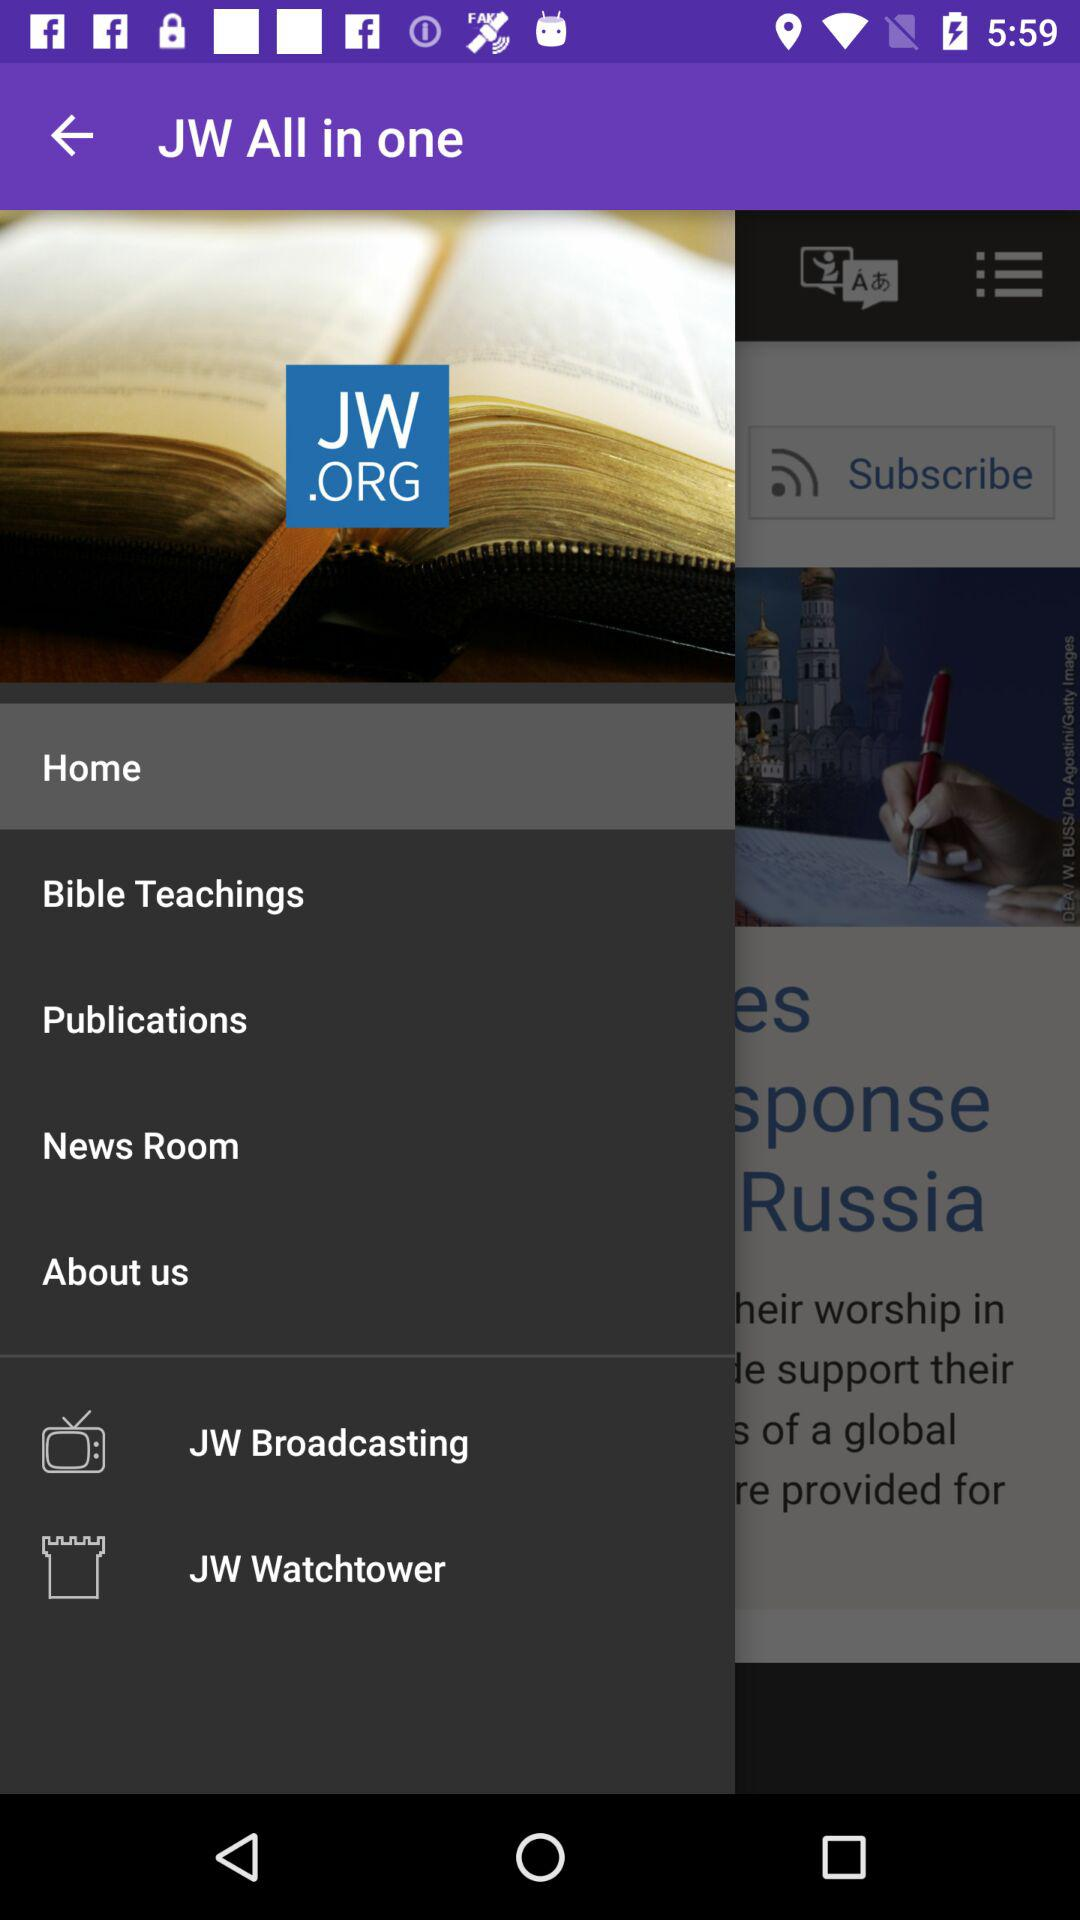What is the application name?
When the provided information is insufficient, respond with <no answer>. <no answer> 